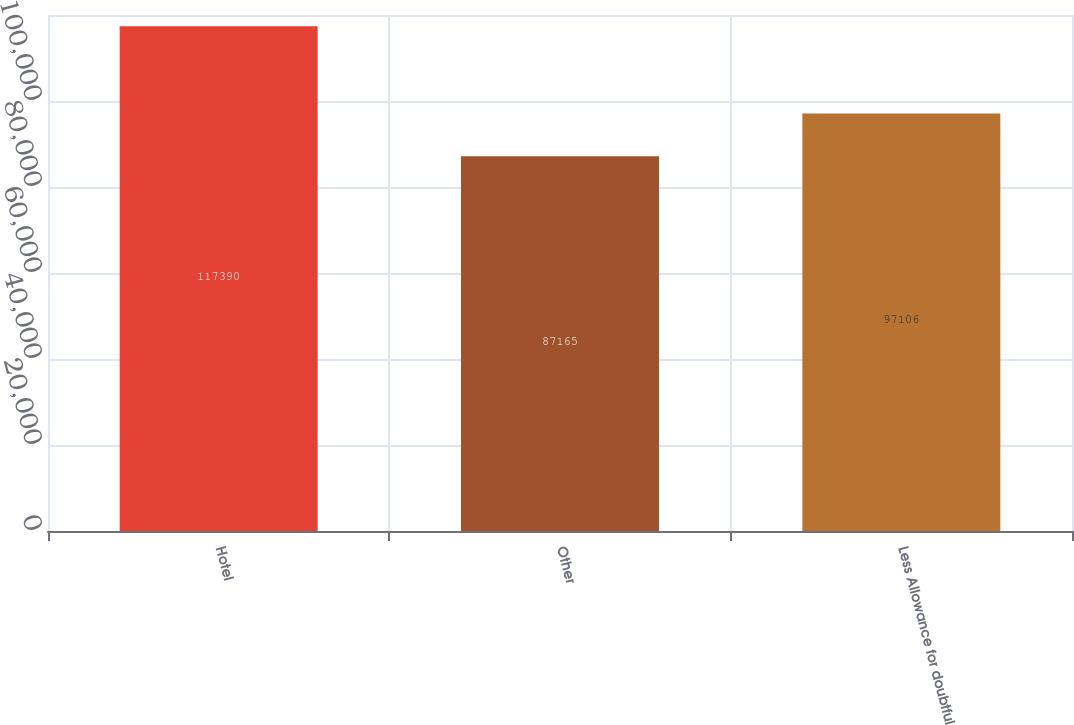Convert chart to OTSL. <chart><loc_0><loc_0><loc_500><loc_500><bar_chart><fcel>Hotel<fcel>Other<fcel>Less Allowance for doubtful<nl><fcel>117390<fcel>87165<fcel>97106<nl></chart> 